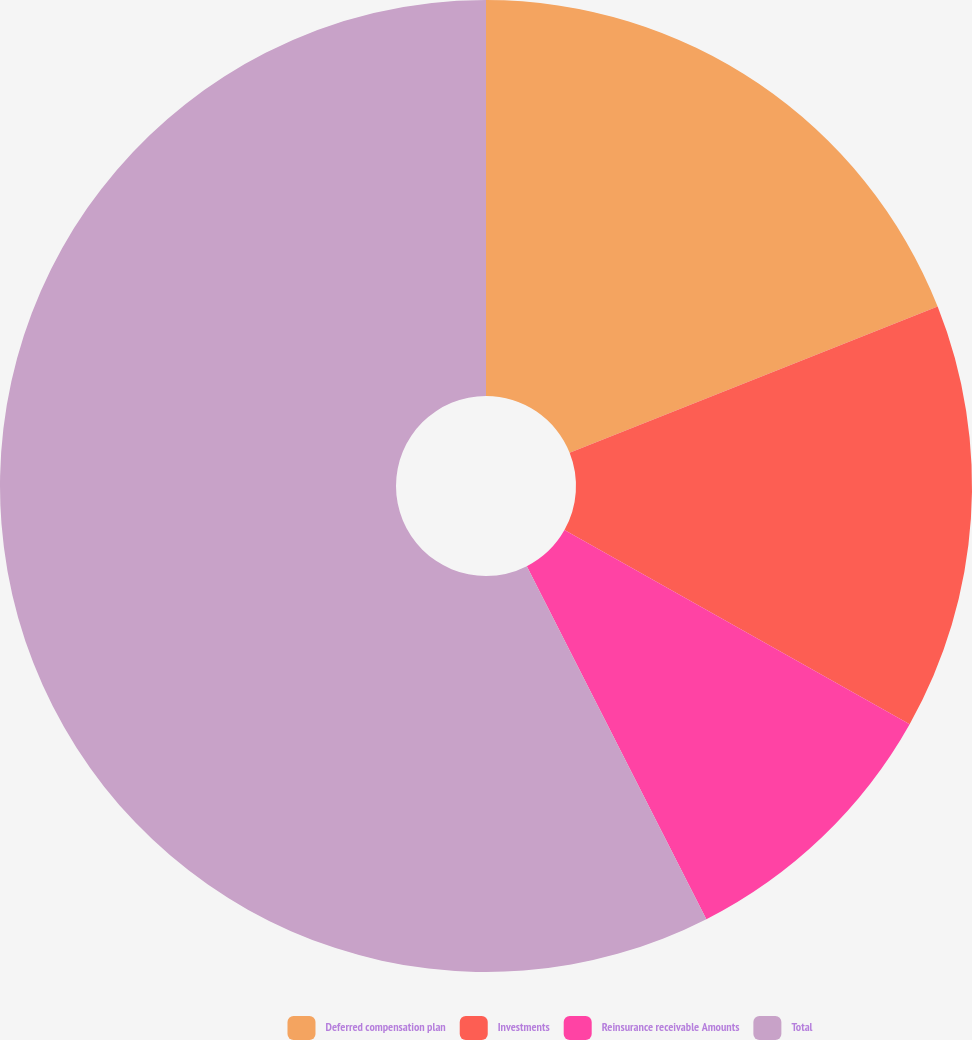Convert chart to OTSL. <chart><loc_0><loc_0><loc_500><loc_500><pie_chart><fcel>Deferred compensation plan<fcel>Investments<fcel>Reinsurance receivable Amounts<fcel>Total<nl><fcel>18.98%<fcel>14.17%<fcel>9.36%<fcel>57.49%<nl></chart> 